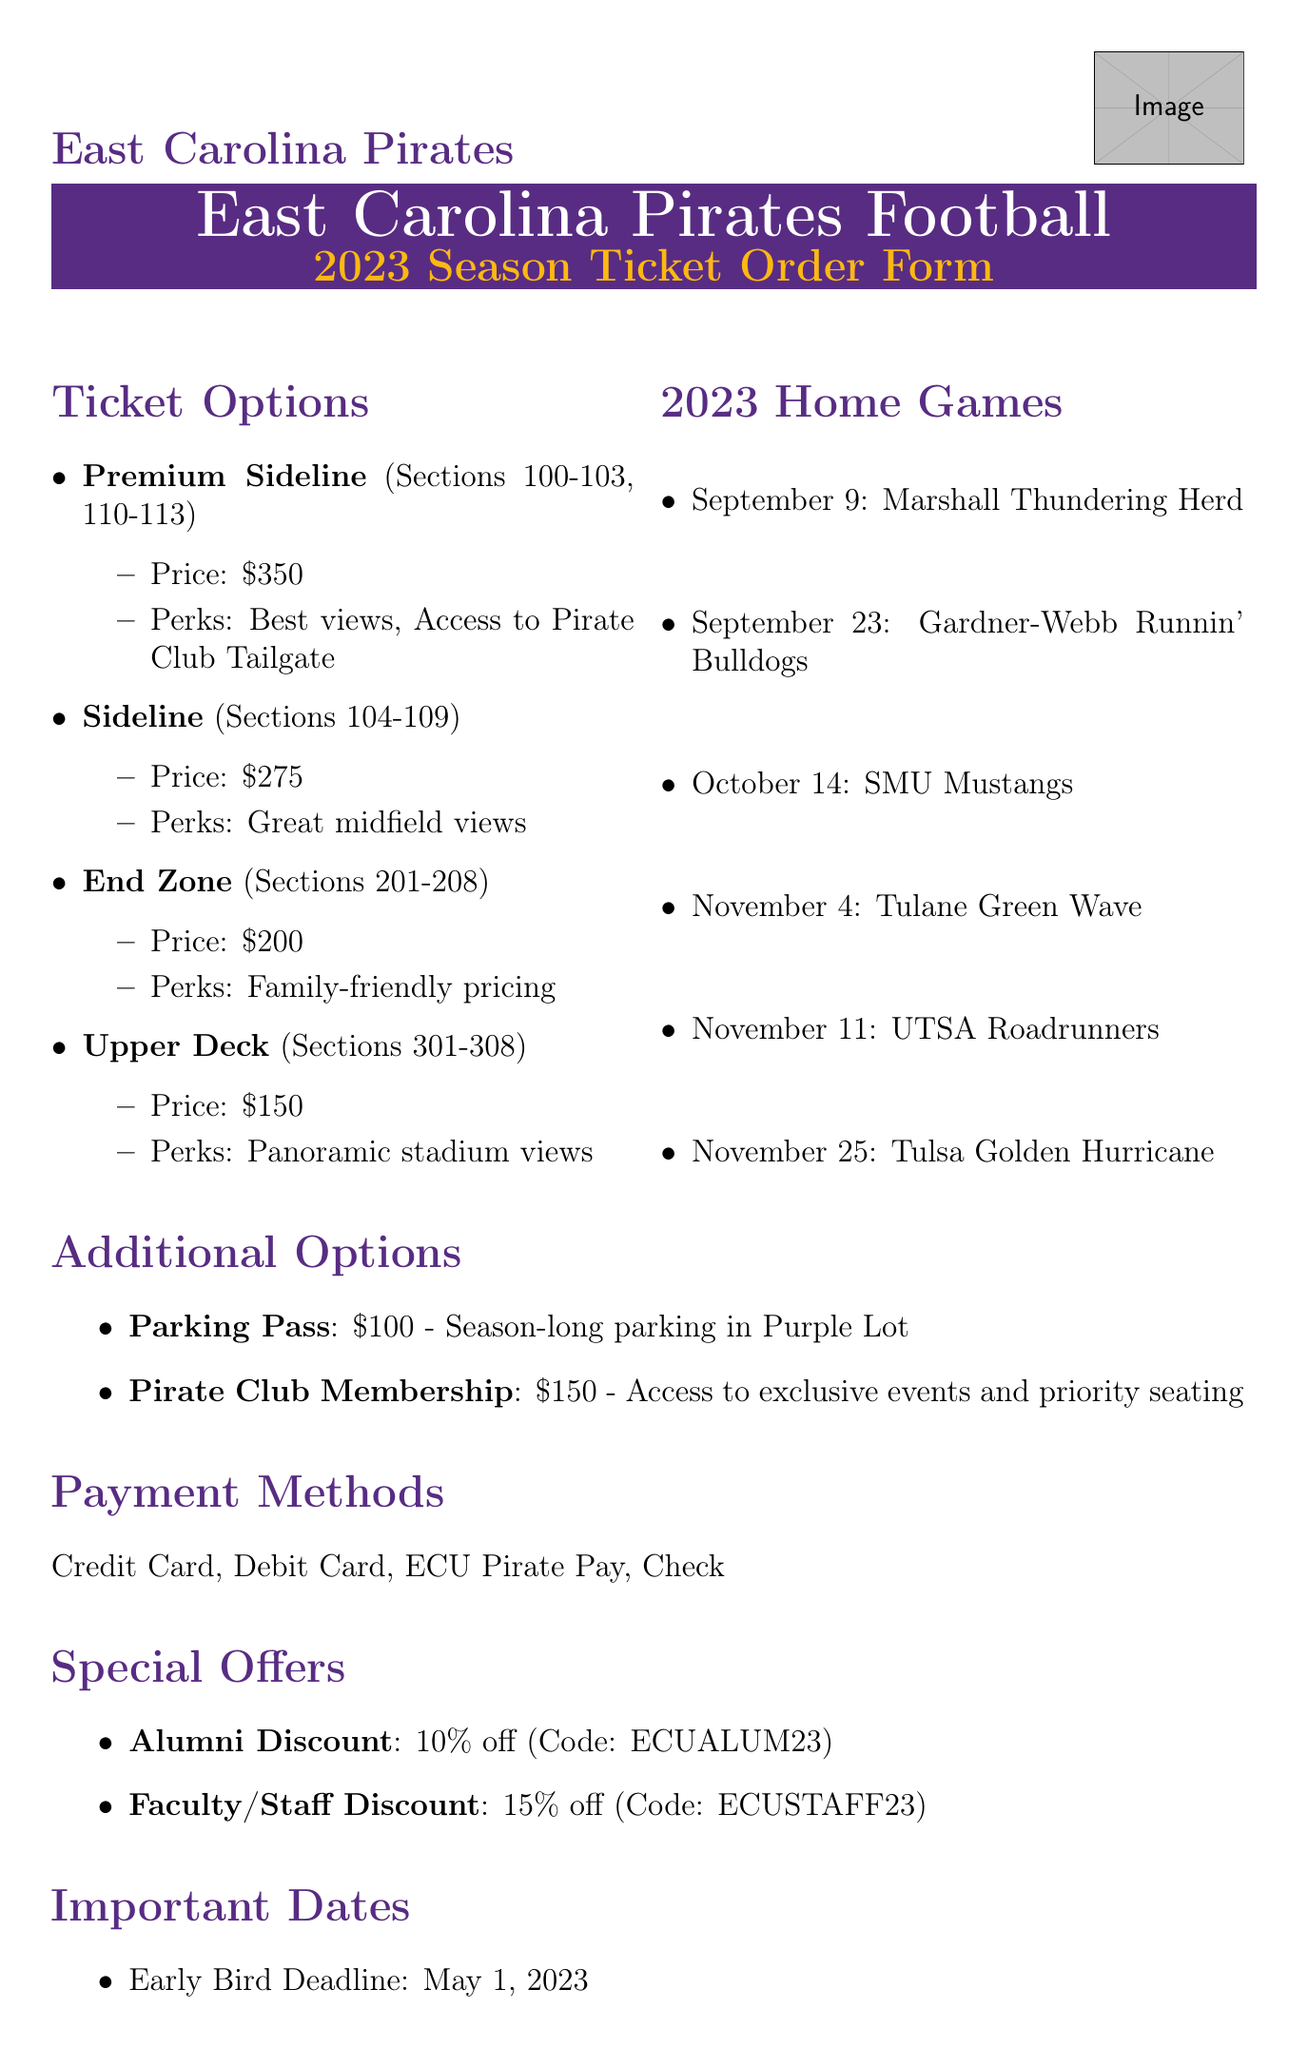what is the price of Premium Sideline tickets? The price for Premium Sideline tickets is listed in the ticket options section of the document.
Answer: 350 which section do Sideline tickets cover? The section for Sideline tickets is specified in the ticket options section.
Answer: 104-109 how many home games are listed? The total count of home games can be derived from the home games section in the document.
Answer: 6 what is the parking pass price? The parking pass price is detailed in the additional options section of the document.
Answer: 100 what is the discount for alumni? The alumni discount is specified in the special offers section, detailing the percentage off.
Answer: 10% off when is the regular deadline for season ticket orders? The regular deadline is stated in the important dates section of the document.
Answer: August 1, 2023 what is the venue for the ECU Pirates football games? The venue is mentioned in the contact information section of the document.
Answer: Dowdy-Ficklen Stadium what perks come with End Zone tickets? The perks associated with End Zone tickets are listed in the ticket options section.
Answer: Family-friendly pricing what payment methods are available? The document lists various payment methods in their respective section.
Answer: Credit Card, Debit Card, ECU Pirate Pay, Check 